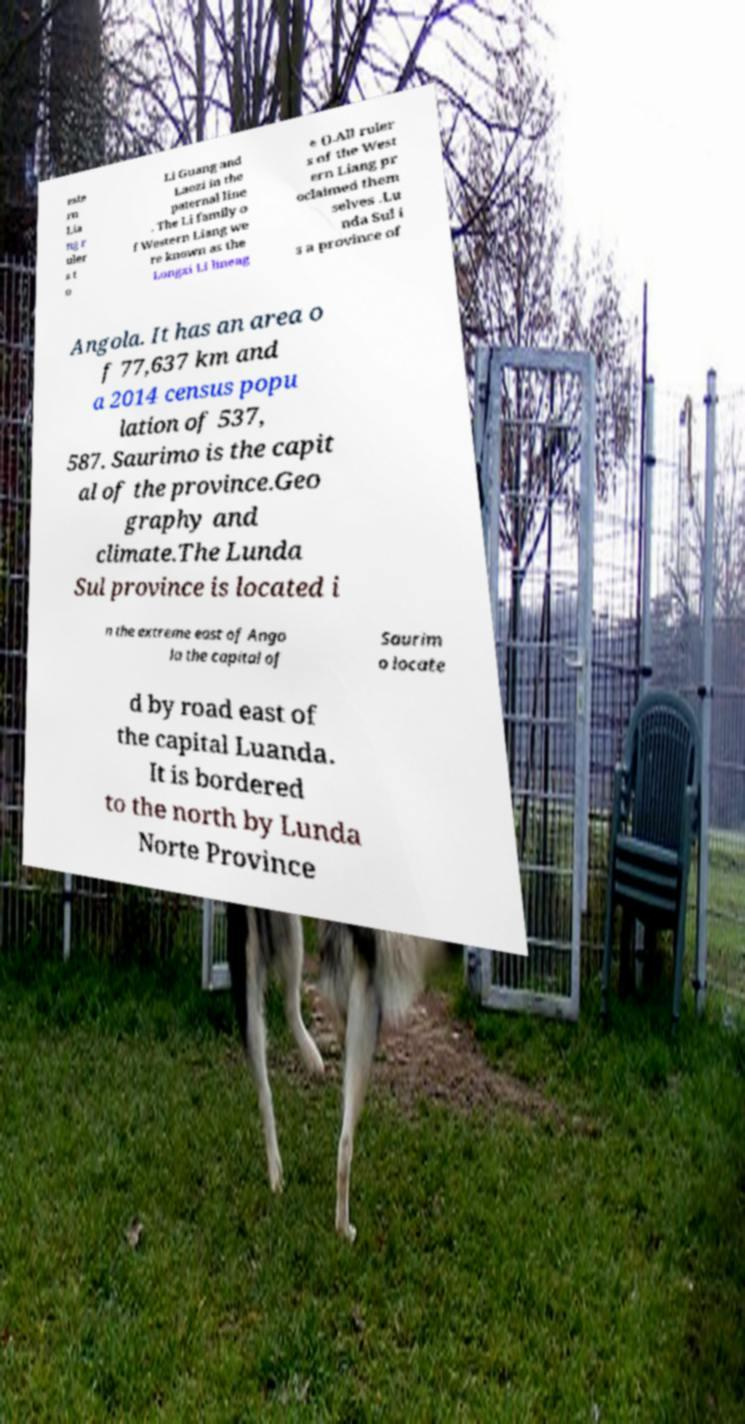Could you assist in decoding the text presented in this image and type it out clearly? este rn Lia ng r uler s t o Li Guang and Laozi in the paternal line . The Li family o f Western Liang we re known as the Longxi Li lineag e ().All ruler s of the West ern Liang pr oclaimed them selves .Lu nda Sul i s a province of Angola. It has an area o f 77,637 km and a 2014 census popu lation of 537, 587. Saurimo is the capit al of the province.Geo graphy and climate.The Lunda Sul province is located i n the extreme east of Ango la the capital of Saurim o locate d by road east of the capital Luanda. It is bordered to the north by Lunda Norte Province 